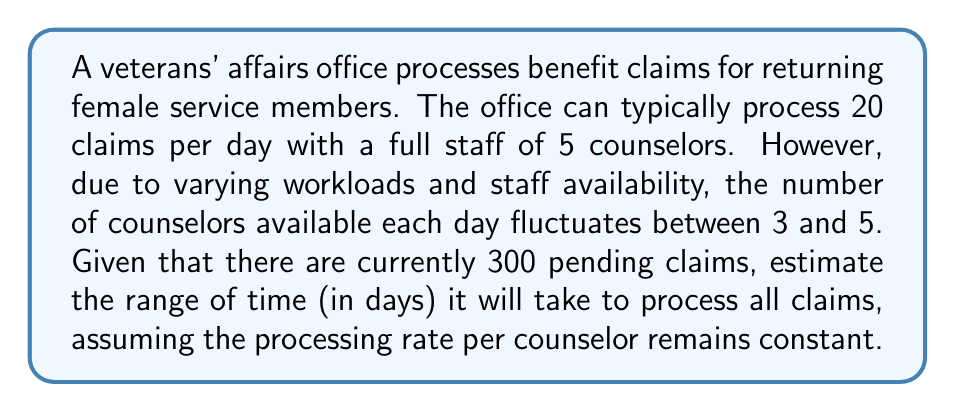Solve this math problem. 1. Calculate the processing rate per counselor:
   $$\text{Rate per counselor} = \frac{20 \text{ claims}}{5 \text{ counselors}} = 4 \text{ claims per counselor per day}$$

2. Calculate the range of claims processed per day:
   - Minimum: $3 \text{ counselors} \times 4 \text{ claims} = 12 \text{ claims per day}$
   - Maximum: $5 \text{ counselors} \times 4 \text{ claims} = 20 \text{ claims per day}$

3. Calculate the range of days to process 300 claims:
   - Maximum days: $\frac{300 \text{ claims}}{12 \text{ claims per day}} = 25 \text{ days}$
   - Minimum days: $\frac{300 \text{ claims}}{20 \text{ claims per day}} = 15 \text{ days}$

Therefore, it will take between 15 and 25 days to process all 300 claims.
Answer: $[15, 25]$ days 